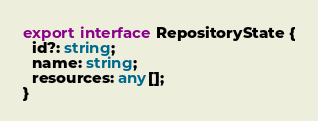<code> <loc_0><loc_0><loc_500><loc_500><_TypeScript_>export interface RepositoryState {
  id?: string;
  name: string;
  resources: any[];
}
</code> 